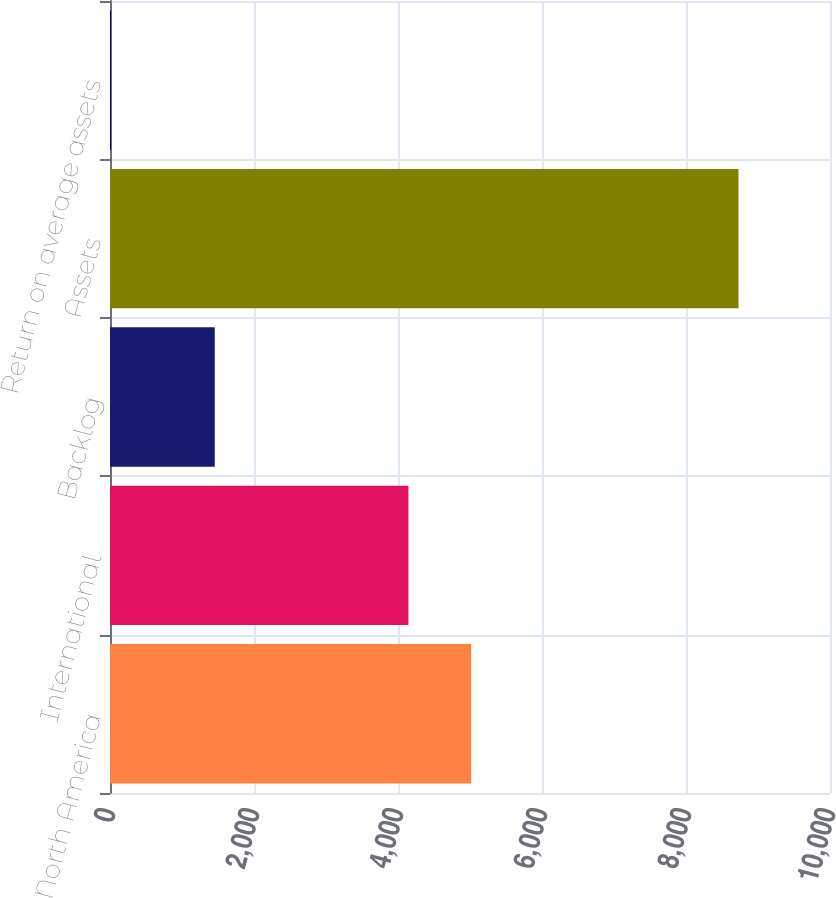Convert chart. <chart><loc_0><loc_0><loc_500><loc_500><bar_chart><fcel>North America<fcel>International<fcel>Backlog<fcel>Assets<fcel>Return on average assets<nl><fcel>5016.48<fcel>4145<fcel>1455<fcel>8729<fcel>14.2<nl></chart> 